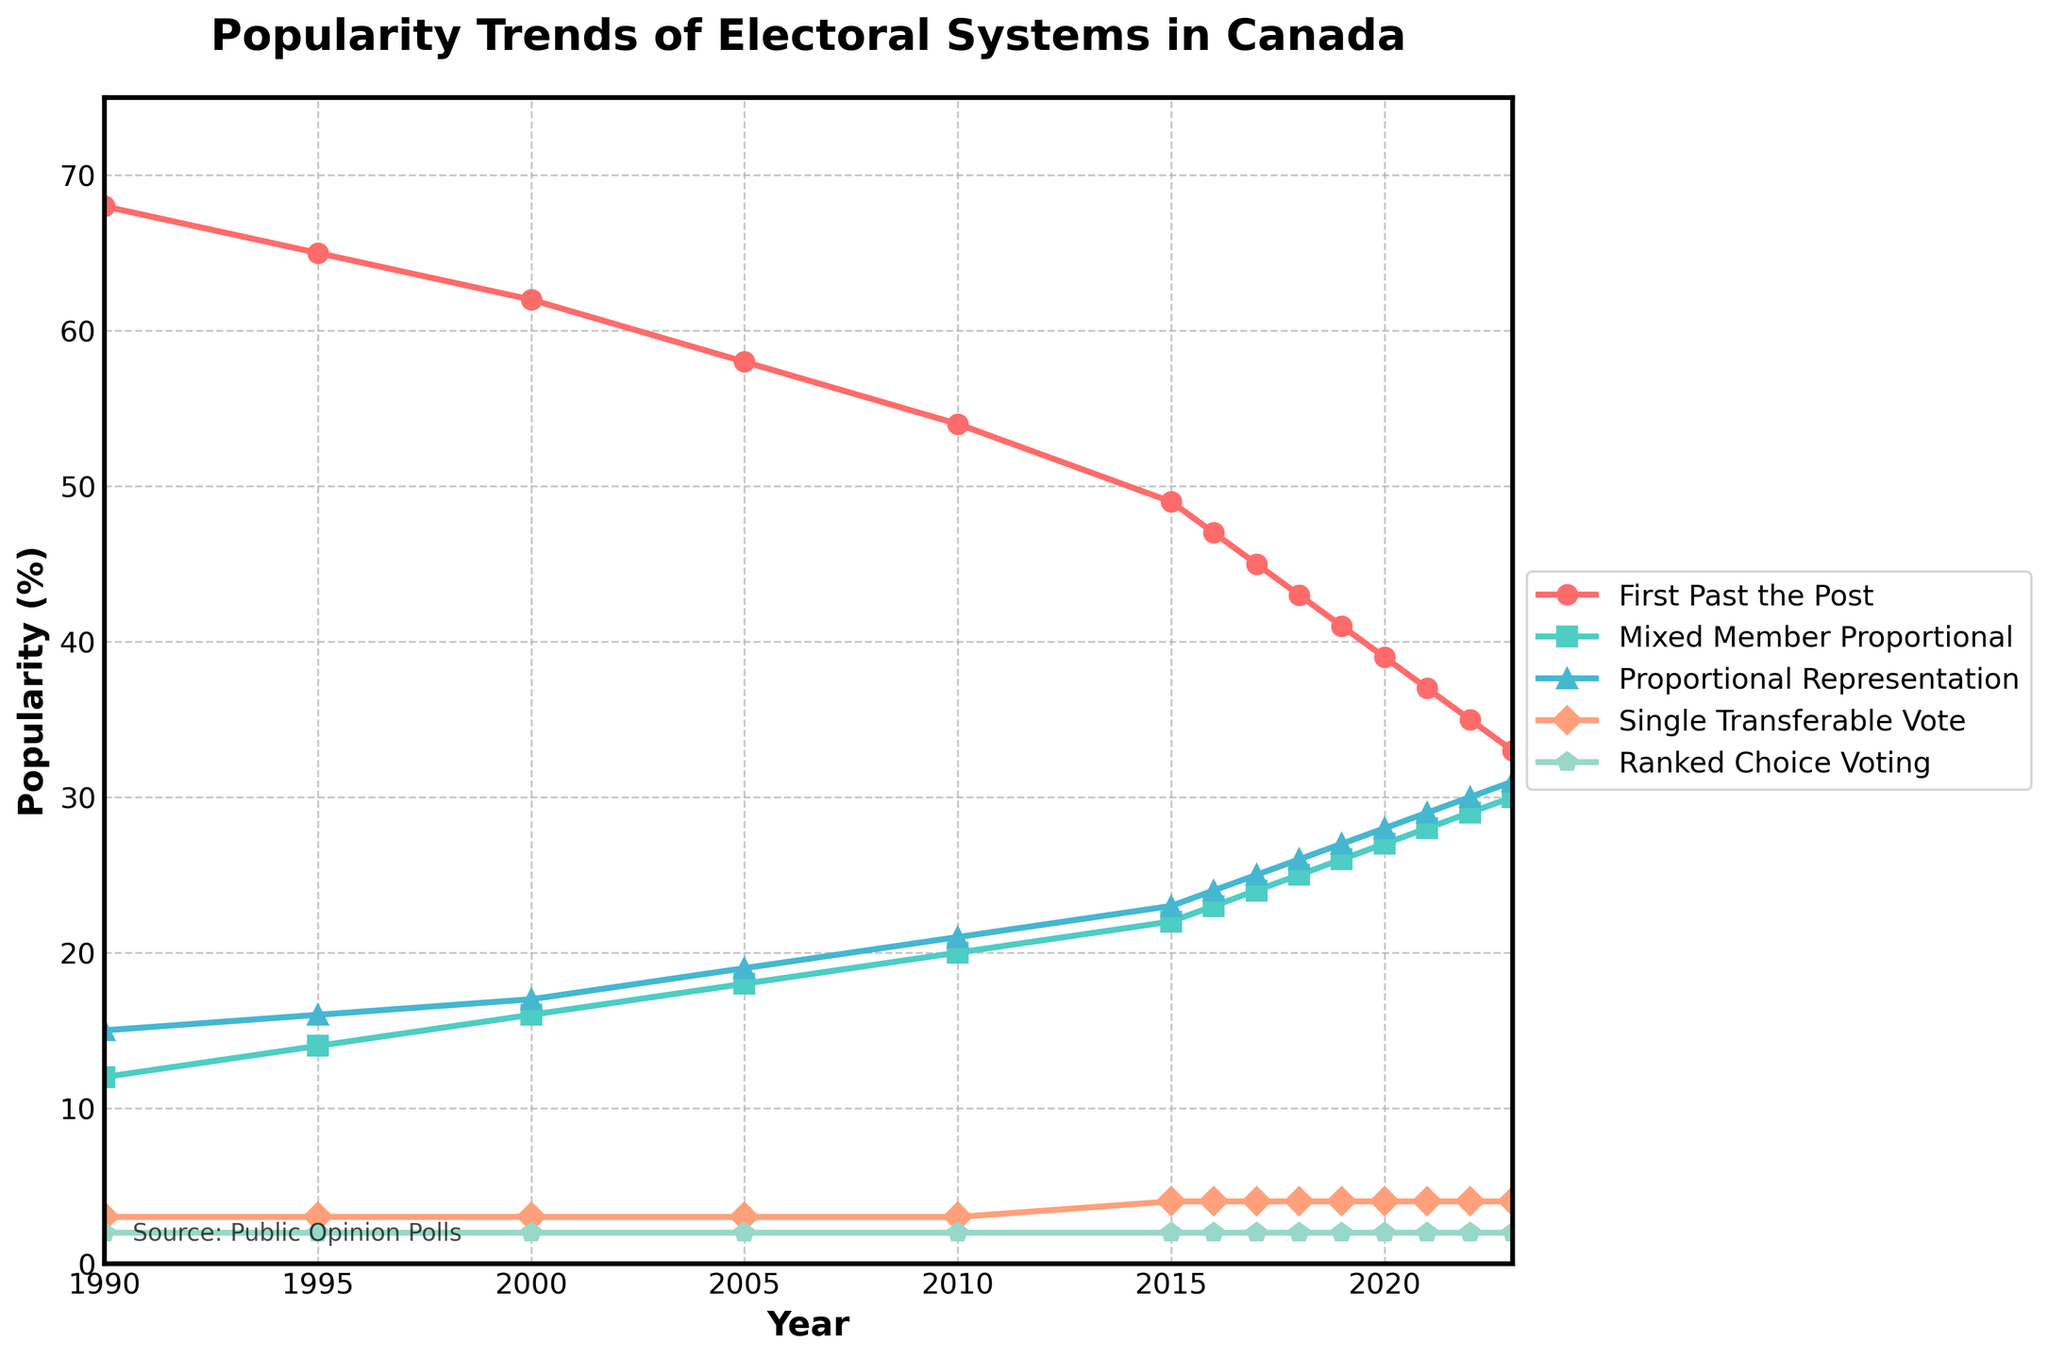What's the trend for the popularity of the First Past the Post system from 1990 to 2023? The First Past the Post system shows a consistent decline in popularity from 68% in 1990 to 33% in 2023.
Answer: Consistent decline Which electoral system had the highest popularity in 2023? In 2023, the First Past the Post system had the highest popularity at 33%, although its popularity has been declining.
Answer: First Past the Post How did the popularity of the Mixed Member Proportional system change from 2000 to 2020? In 2000, the popularity of the Mixed Member Proportional system was 16%, which increased to 27% by 2020.
Answer: Increased What is the difference in popularity between Proportional Representation and Single Transferable Vote in 2023? In 2023, Proportional Representation had a popularity of 31%, while Single Transferable Vote had 4%. The difference is 31% - 4% = 27%.
Answer: 27% Which electoral system showed the least change in popularity from 1990 to 2023? The Ranked Choice Voting system maintained a steady 2% popularity from 1990 to 2023, indicating the least change.
Answer: Ranked Choice Voting What is the average popularity of the Proportional Representation system over the period 1990 to 2023? The popularity values are 15, 16, 17, 19, 21, 23, 24, 25, 26, 27, 28, 29, 30, and 31. Sum these values: 15 + 16 + 17 + 19 + 21 + 23 + 24 + 25 + 26 + 27 + 28 + 29 + 30 + 31 = 351. Divide by 14 years, 351/14 = 25.07.
Answer: 25.07% When did the Mixed Member Proportional system surpass 20% popularity? The Mixed Member Proportional system surpassed 20% popularity in 2010, reaching 20%.
Answer: 2010 What is the color used to represent Ranked Choice Voting in the chart? Ranked Choice Voting is represented by the 5th line in the legend. It is depicted in a color type typically described as light blue or similar.
Answer: Light blue (or similar) By how much did the popularity of Single Transferable Vote increase from 1990 to 2023? The popularity of Single Transferable Vote was 3% in 1990 and 4% in 2023. The increase is 4% - 3% = 1%.
Answer: 1% 